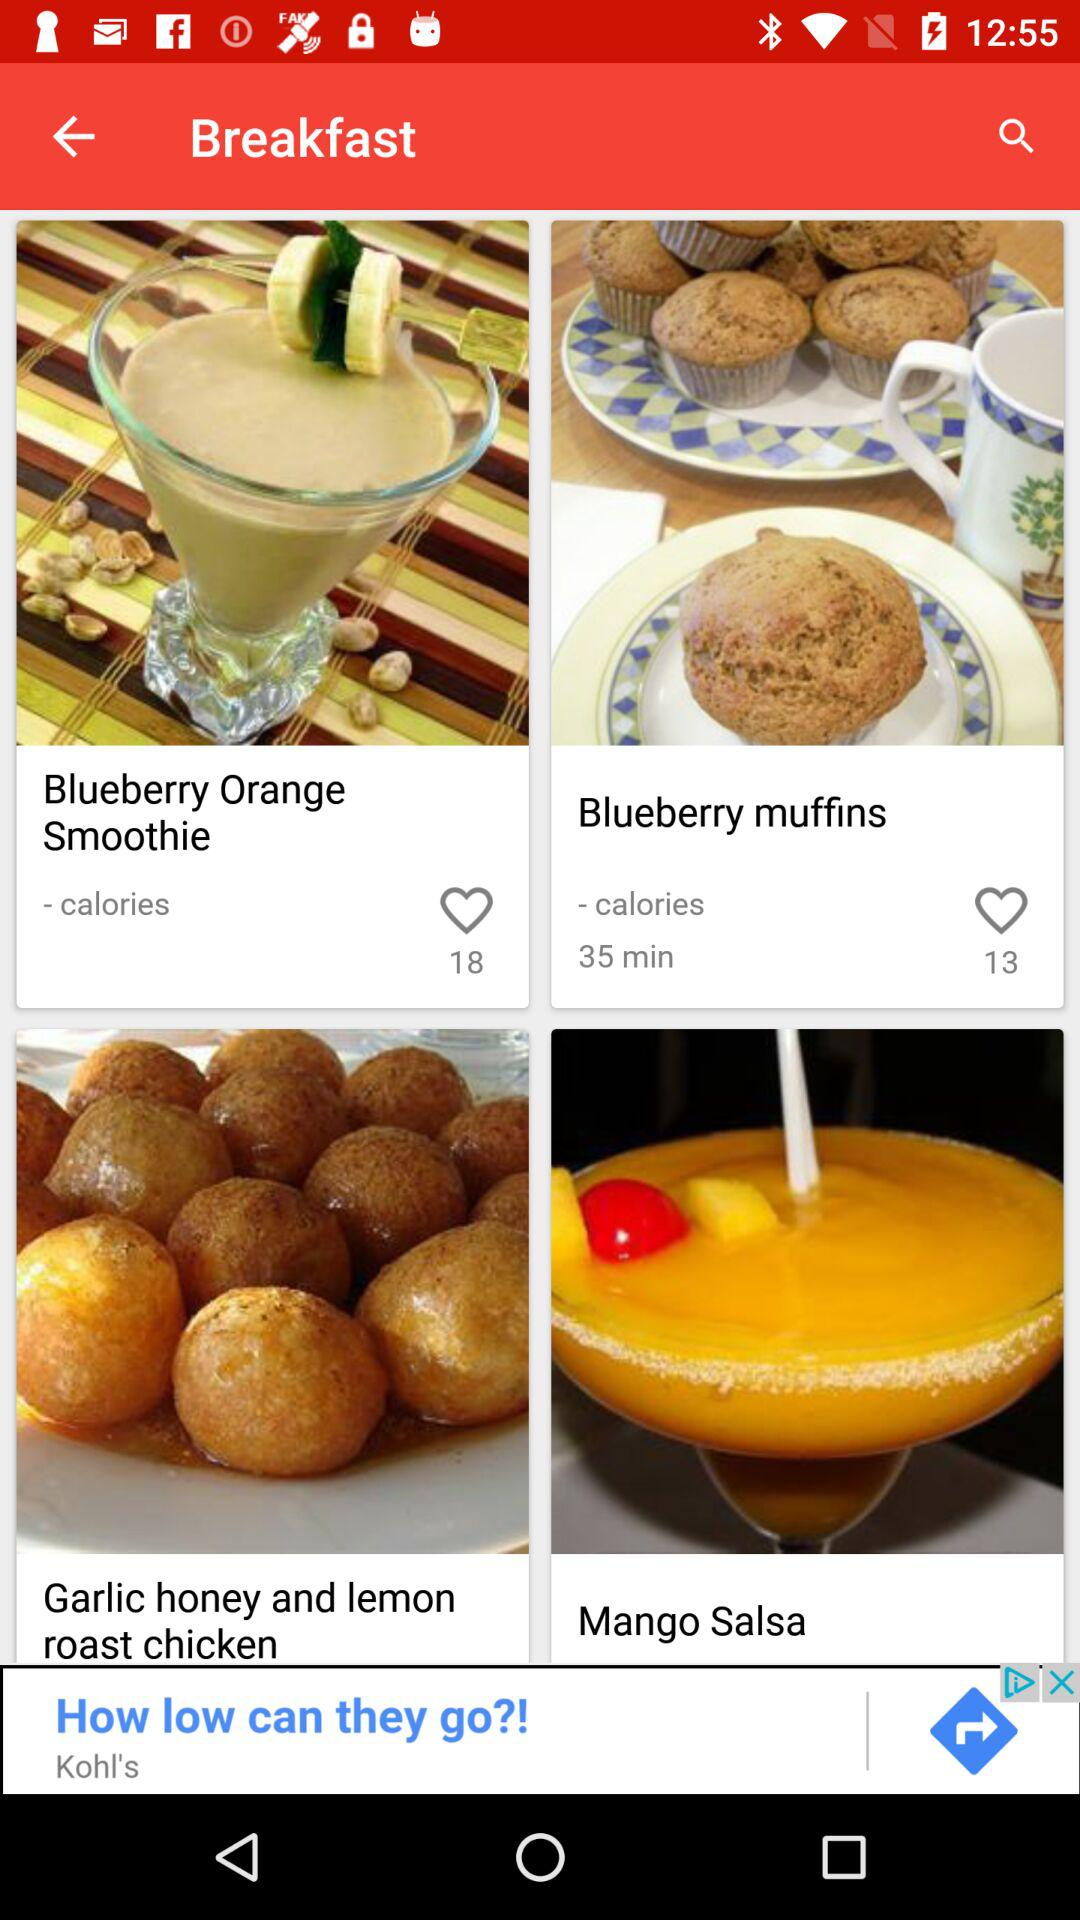How many likes are there for "Blueberry Orange Smoothie"? There are 18 likes for "Blueberry Orange Smoothie". 